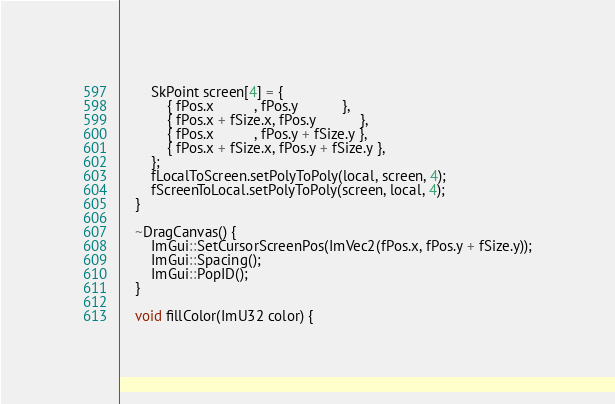Convert code to text. <code><loc_0><loc_0><loc_500><loc_500><_C_>        SkPoint screen[4] = {
            { fPos.x          , fPos.y           },
            { fPos.x + fSize.x, fPos.y           },
            { fPos.x          , fPos.y + fSize.y },
            { fPos.x + fSize.x, fPos.y + fSize.y },
        };
        fLocalToScreen.setPolyToPoly(local, screen, 4);
        fScreenToLocal.setPolyToPoly(screen, local, 4);
    }

    ~DragCanvas() {
        ImGui::SetCursorScreenPos(ImVec2(fPos.x, fPos.y + fSize.y));
        ImGui::Spacing();
        ImGui::PopID();
    }

    void fillColor(ImU32 color) {</code> 